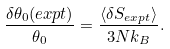Convert formula to latex. <formula><loc_0><loc_0><loc_500><loc_500>\frac { \delta \theta _ { 0 } ( e x p t ) } { \theta _ { 0 } } = \frac { \langle \delta S _ { e x p t } \rangle } { 3 N k _ { B } } .</formula> 